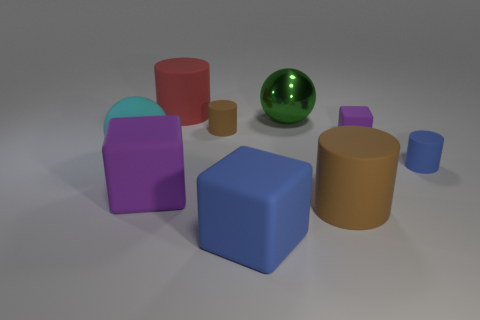Do the large matte cube to the left of the red rubber object and the tiny block have the same color?
Your answer should be very brief. Yes. How big is the block that is both right of the red cylinder and left of the green metal thing?
Ensure brevity in your answer.  Large. What number of other things are the same color as the small rubber block?
Ensure brevity in your answer.  1. What material is the other block that is the same color as the tiny rubber block?
Your answer should be very brief. Rubber. What number of shiny objects are either big things or large blue spheres?
Give a very brief answer. 1. There is a tiny brown matte object; what shape is it?
Offer a very short reply. Cylinder. What number of yellow things are made of the same material as the large blue object?
Your response must be concise. 0. What is the color of the big ball that is the same material as the tiny cube?
Keep it short and to the point. Cyan. Is the size of the brown cylinder that is behind the blue cylinder the same as the red rubber cylinder?
Your answer should be compact. No. What is the color of the other large rubber thing that is the same shape as the large red matte thing?
Keep it short and to the point. Brown. 